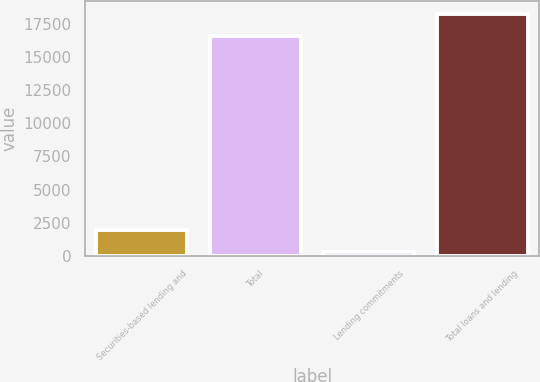Convert chart. <chart><loc_0><loc_0><loc_500><loc_500><bar_chart><fcel>Securities-based lending and<fcel>Total<fcel>Lending commitments<fcel>Total loans and lending<nl><fcel>1960.3<fcel>16593<fcel>301<fcel>18252.3<nl></chart> 